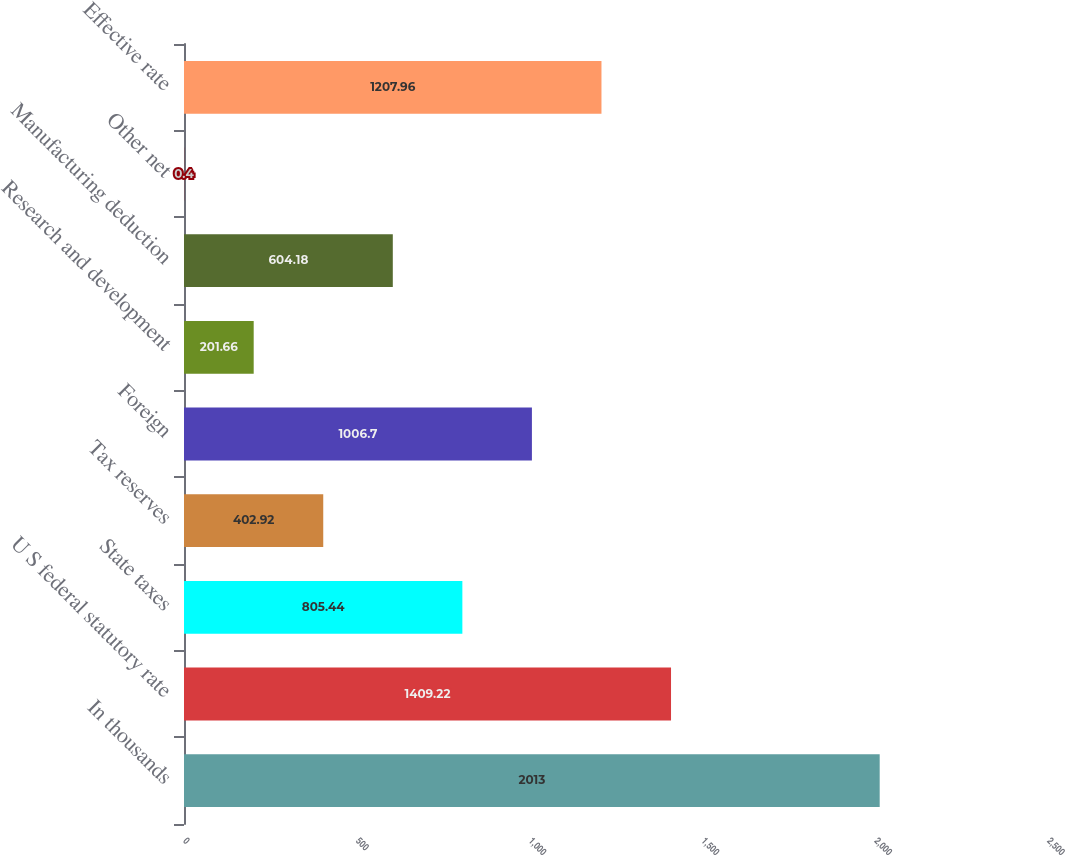Convert chart to OTSL. <chart><loc_0><loc_0><loc_500><loc_500><bar_chart><fcel>In thousands<fcel>U S federal statutory rate<fcel>State taxes<fcel>Tax reserves<fcel>Foreign<fcel>Research and development<fcel>Manufacturing deduction<fcel>Other net<fcel>Effective rate<nl><fcel>2013<fcel>1409.22<fcel>805.44<fcel>402.92<fcel>1006.7<fcel>201.66<fcel>604.18<fcel>0.4<fcel>1207.96<nl></chart> 